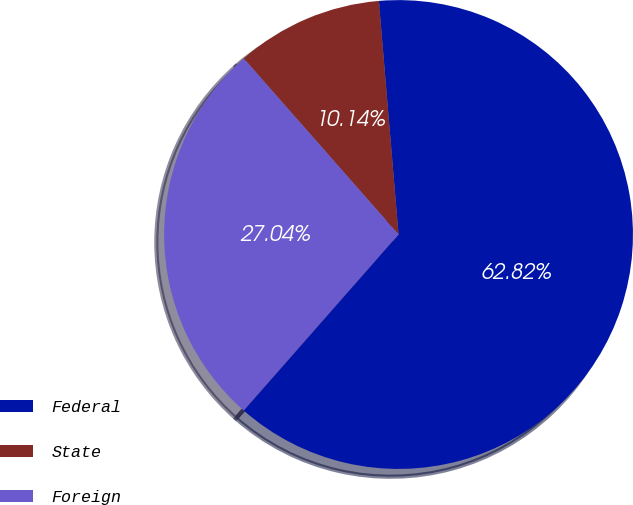Convert chart to OTSL. <chart><loc_0><loc_0><loc_500><loc_500><pie_chart><fcel>Federal<fcel>State<fcel>Foreign<nl><fcel>62.81%<fcel>10.14%<fcel>27.04%<nl></chart> 